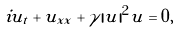<formula> <loc_0><loc_0><loc_500><loc_500>i u _ { t } + u _ { x x } + \gamma | u | ^ { 2 } u = 0 ,</formula> 